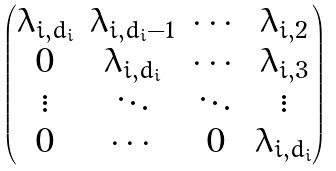<formula> <loc_0><loc_0><loc_500><loc_500>\begin{pmatrix} \lambda _ { i , d _ { i } } & \lambda _ { i , d _ { i } - 1 } & \cdots & \lambda _ { i , 2 } \\ 0 & \lambda _ { i , d _ { i } } & \cdots & \lambda _ { i , 3 } \\ \vdots & \ddots & \ddots & \vdots \\ 0 & \cdots & 0 & \lambda _ { i , d _ { i } } \end{pmatrix}</formula> 